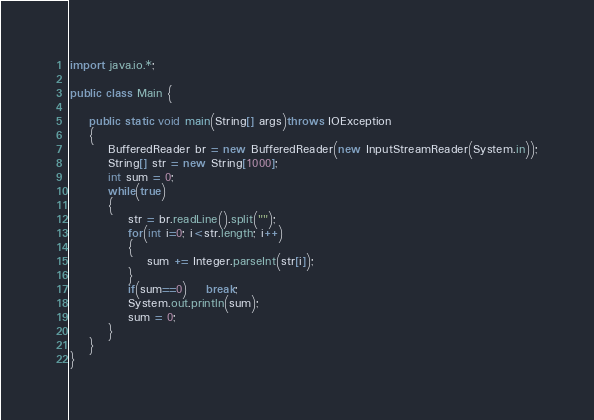Convert code to text. <code><loc_0><loc_0><loc_500><loc_500><_Java_>import java.io.*;

public class Main {

	public static void main(String[] args)throws IOException
	{
		BufferedReader br = new BufferedReader(new InputStreamReader(System.in));
		String[] str = new String[1000];
		int sum = 0;
		while(true)
		{
			str = br.readLine().split("");
			for(int i=0; i<str.length; i++)
			{
				sum += Integer.parseInt(str[i]);
			}
			if(sum==0)	break;
			System.out.println(sum);
			sum = 0;
		}
	}
}</code> 